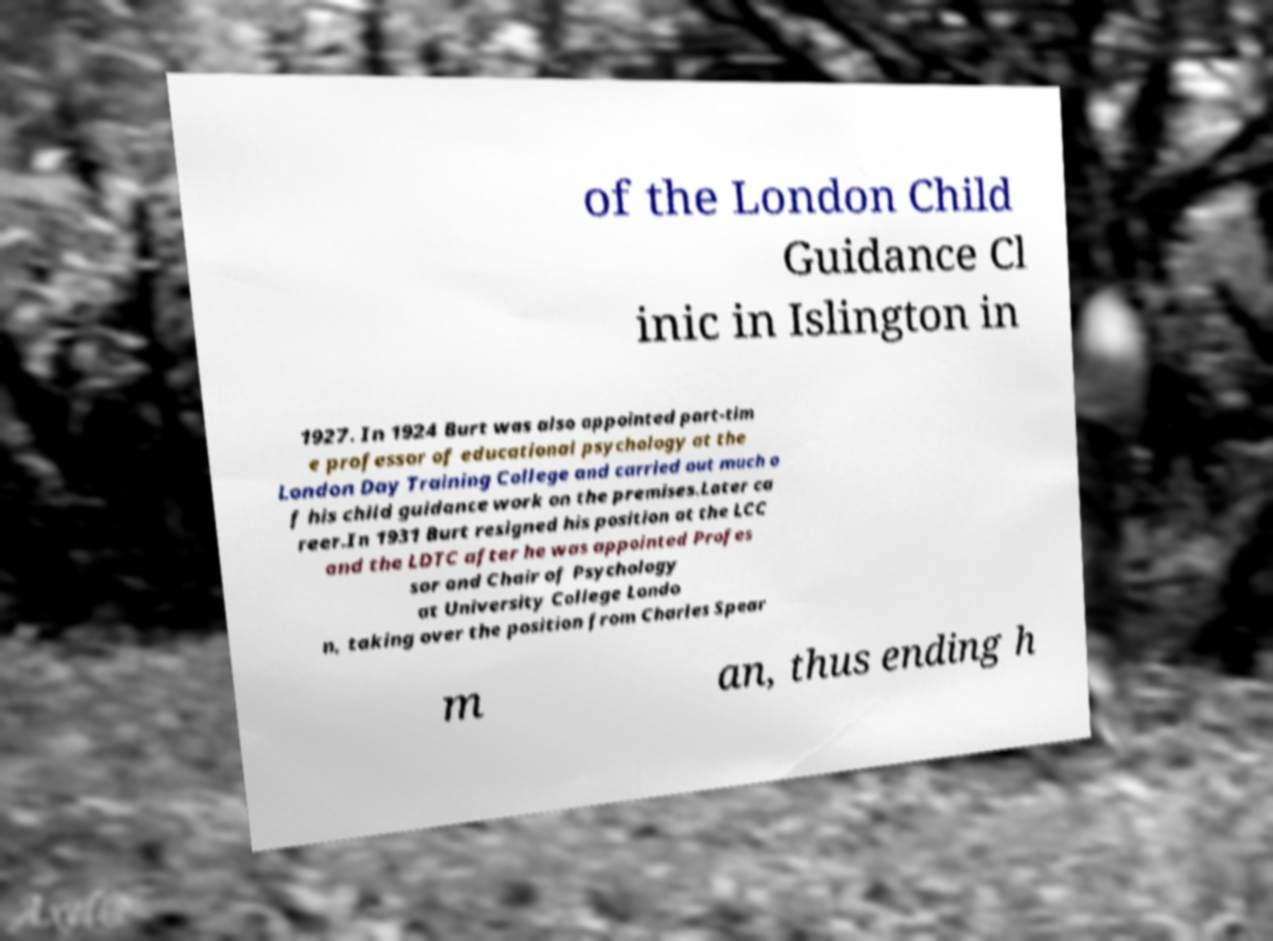Please read and relay the text visible in this image. What does it say? of the London Child Guidance Cl inic in Islington in 1927. In 1924 Burt was also appointed part-tim e professor of educational psychology at the London Day Training College and carried out much o f his child guidance work on the premises.Later ca reer.In 1931 Burt resigned his position at the LCC and the LDTC after he was appointed Profes sor and Chair of Psychology at University College Londo n, taking over the position from Charles Spear m an, thus ending h 